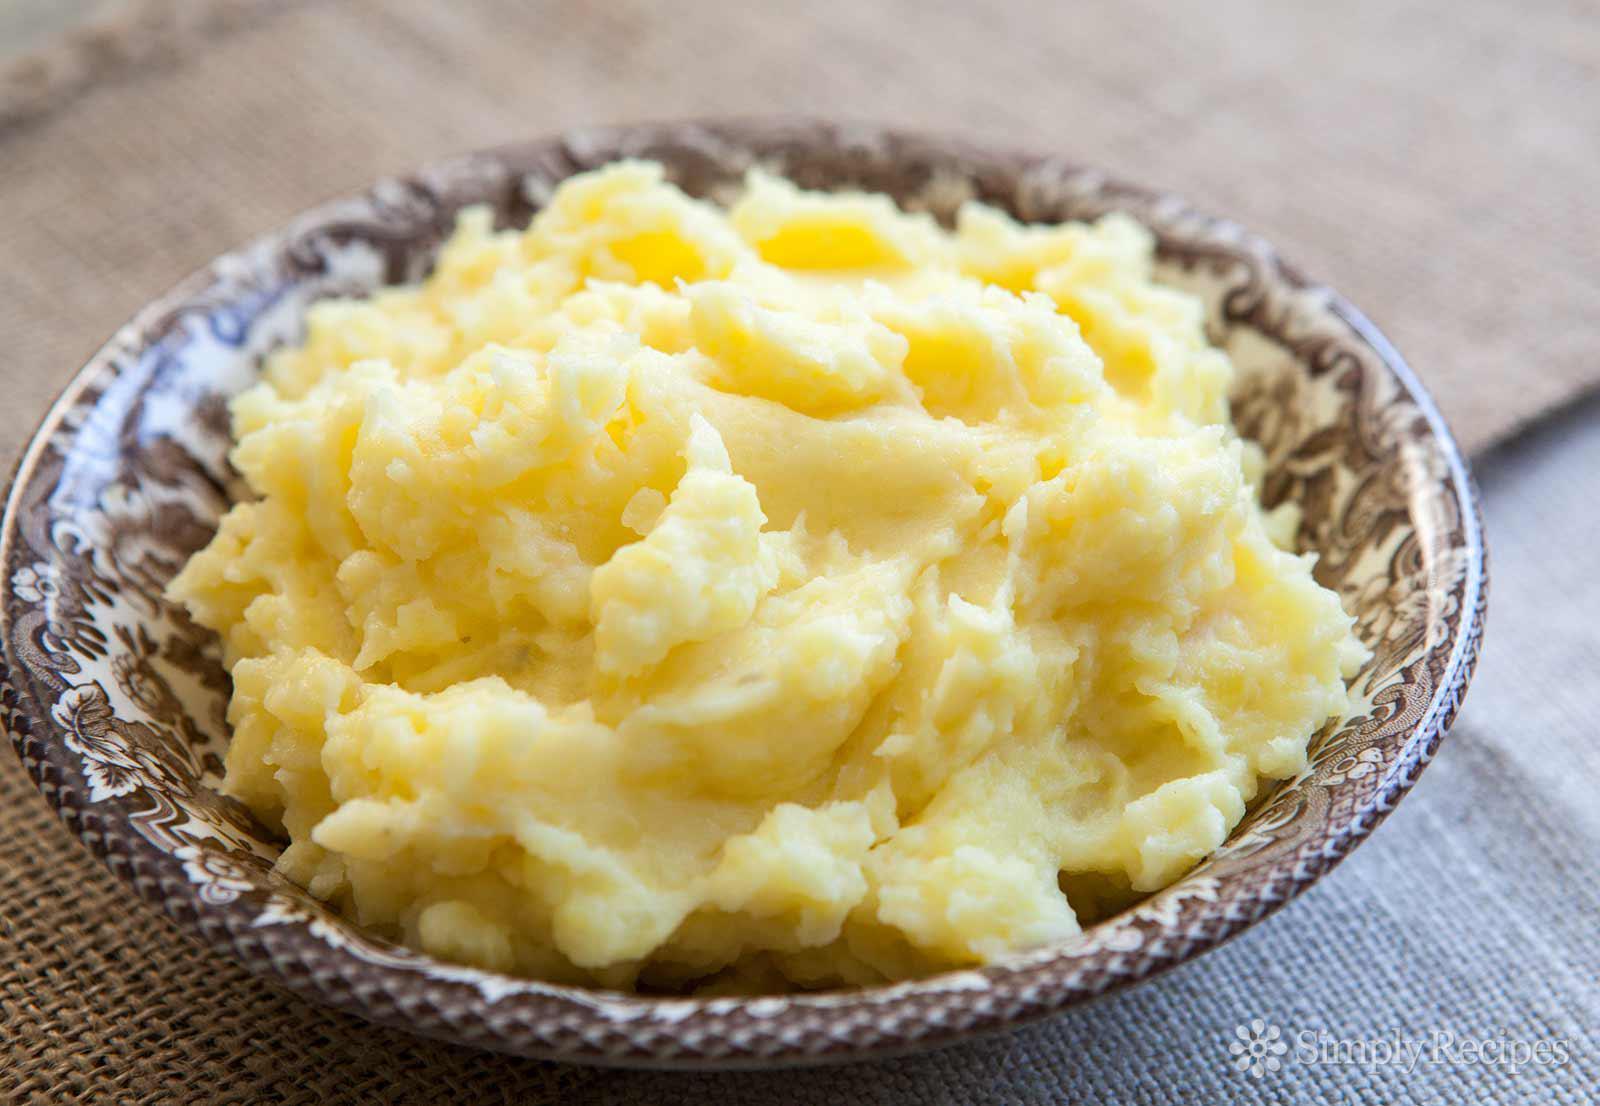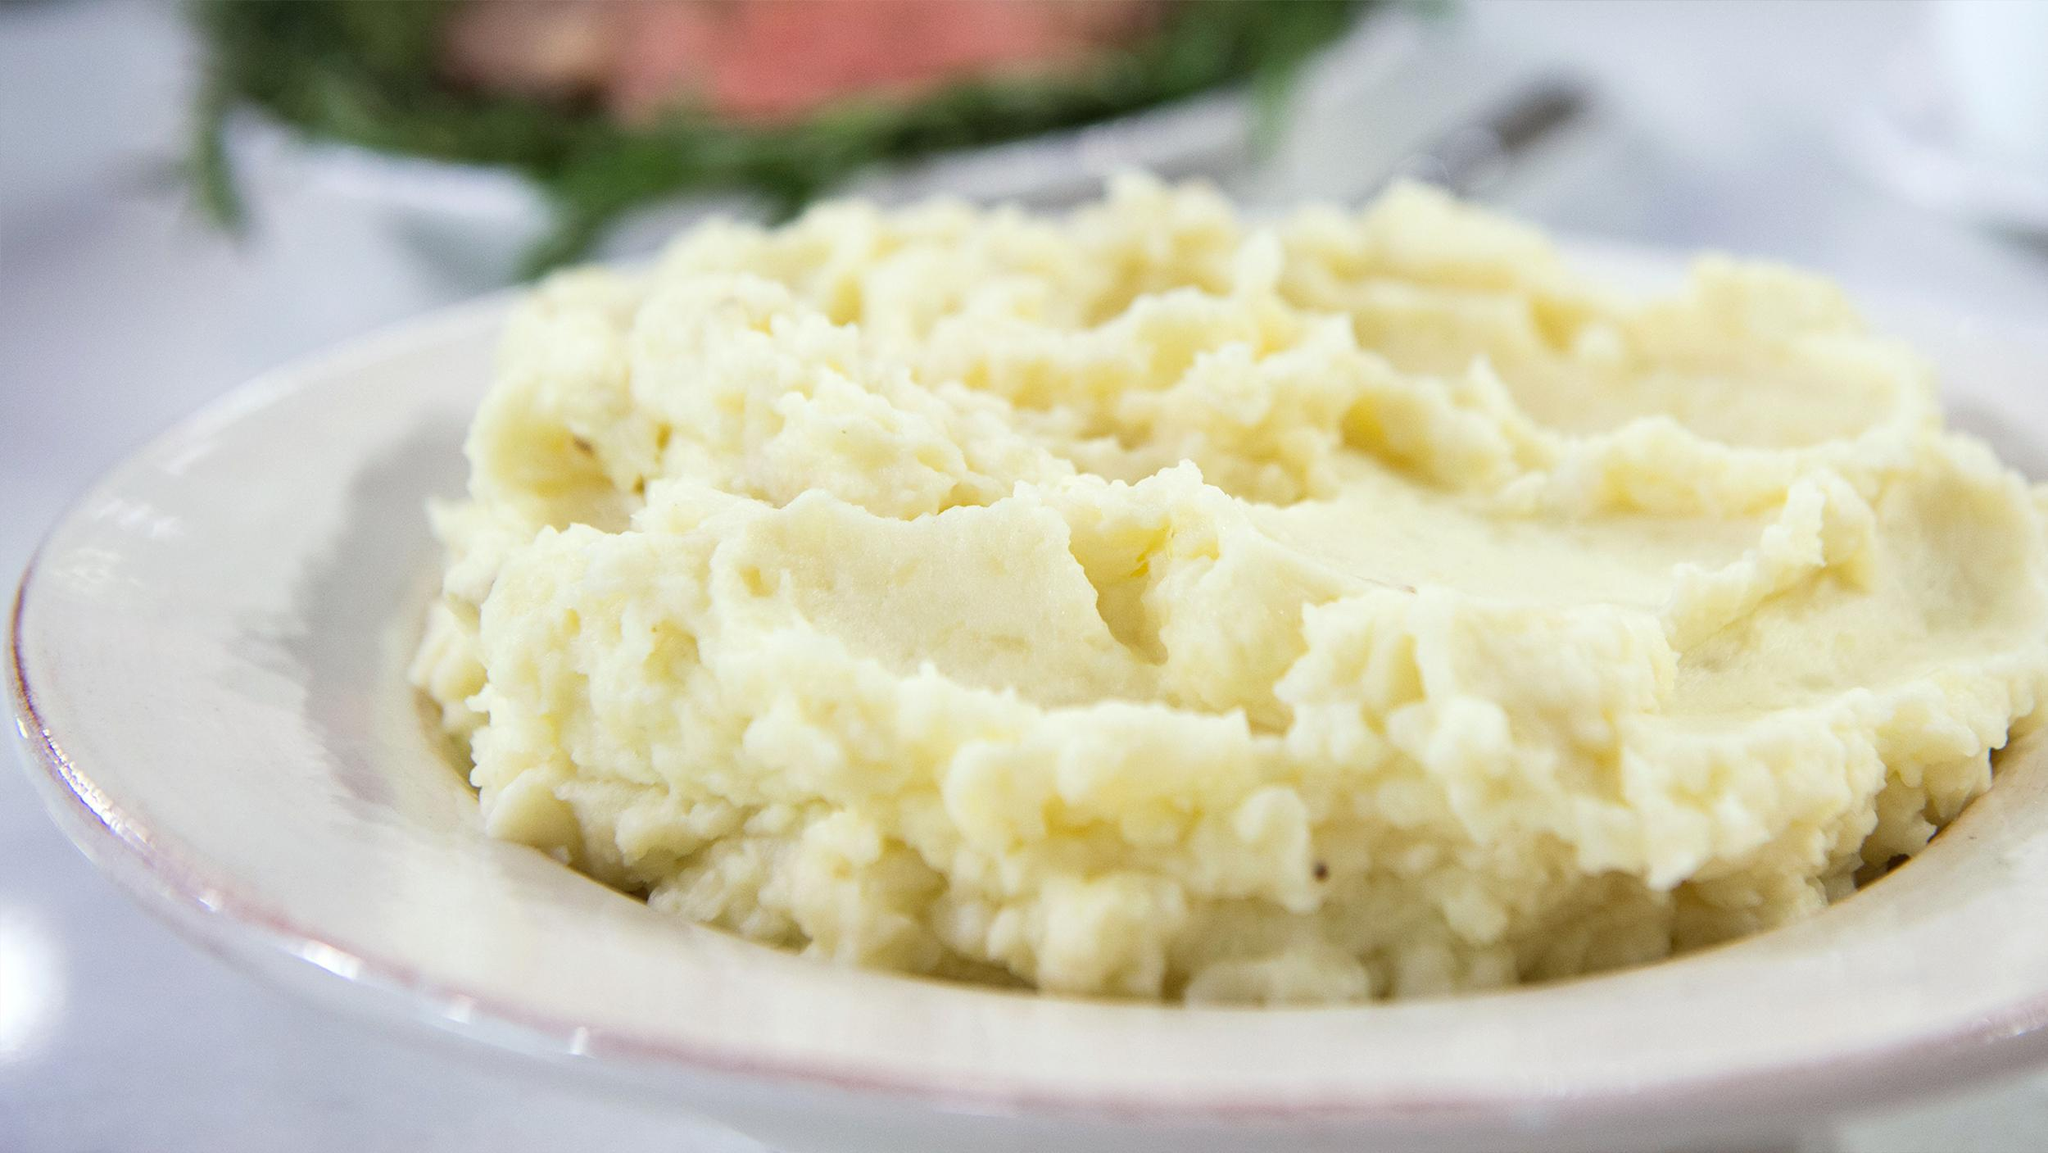The first image is the image on the left, the second image is the image on the right. Assess this claim about the two images: "The image on the right shows a mashed potato on a white bowl.". Correct or not? Answer yes or no. Yes. 